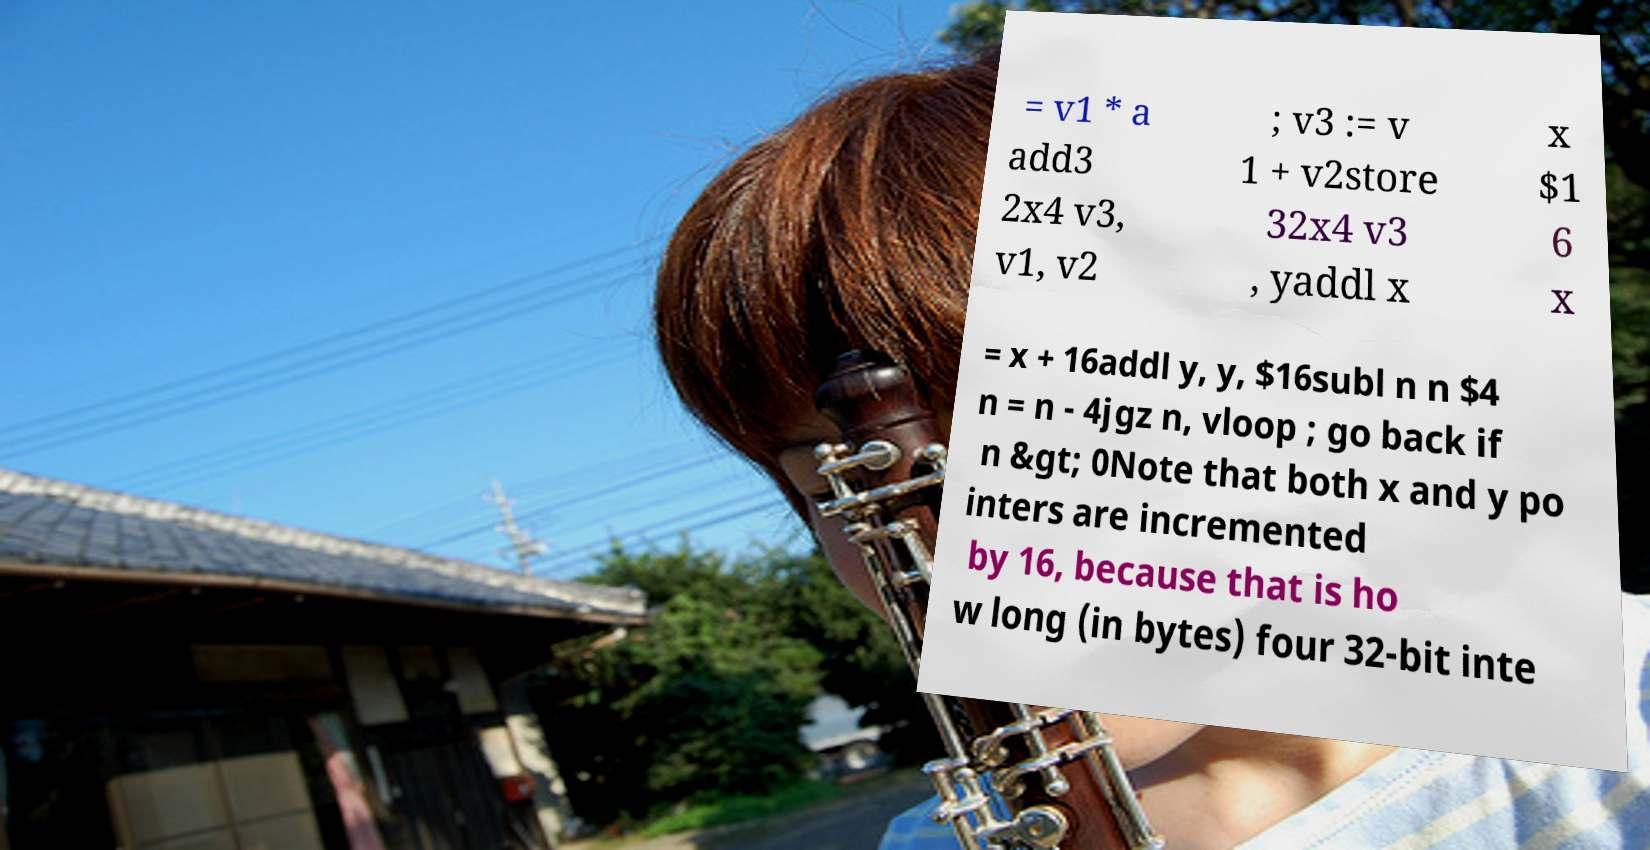Could you assist in decoding the text presented in this image and type it out clearly? = v1 * a add3 2x4 v3, v1, v2 ; v3 := v 1 + v2store 32x4 v3 , yaddl x x $1 6 x = x + 16addl y, y, $16subl n n $4 n = n - 4jgz n, vloop ; go back if n &gt; 0Note that both x and y po inters are incremented by 16, because that is ho w long (in bytes) four 32-bit inte 